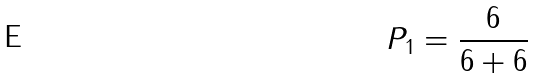Convert formula to latex. <formula><loc_0><loc_0><loc_500><loc_500>P _ { 1 } = \frac { 6 } { 6 + 6 }</formula> 